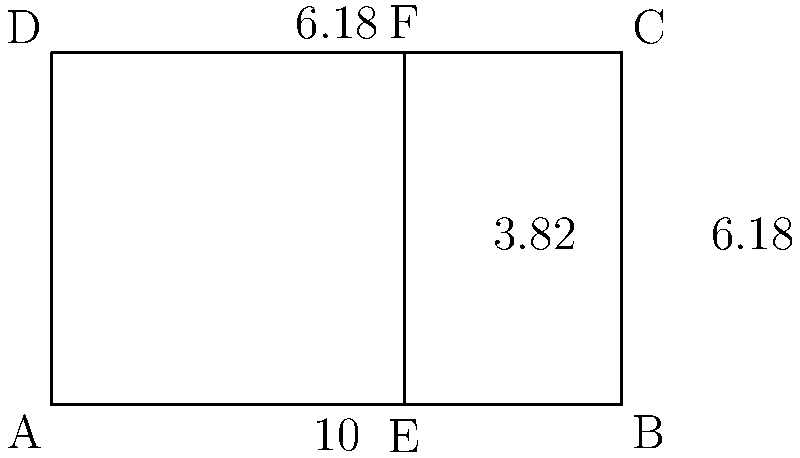In your latest architectural photograph of a building in Buenos Aires, you notice a rectangular facade with golden ratio proportions. The facade is 10 meters wide and 6.18 meters tall. If you divide this rectangle vertically to create two smaller rectangles, with the left rectangle being a perfect square, what is the area of the right rectangle in square meters? Let's approach this step-by-step:

1) The golden ratio is approximately 1.618. In this case, the ratio of width to height is 10 : 6.18, which is indeed the golden ratio.

2) To divide the rectangle according to the golden ratio, we need to find the point where:
   $\frac{\text{total width}}{\text{larger part}} = \frac{\text{larger part}}{\text{smaller part}} = \phi$ (golden ratio)

3) Let $x$ be the width of the square (smaller part). Then:
   $\frac{10}{10-x} = \frac{10-x}{x} = \phi$

4) This gives us the equation: $x^2 + 10x - 100 = 0$

5) Solving this quadratic equation:
   $x = \frac{-10 + \sqrt{100 + 400}}{2} = \frac{-10 + \sqrt{500}}{2} \approx 3.82$

6) So the width of the square (left rectangle) is approximately 3.82 meters.

7) The width of the right rectangle is therefore: $10 - 3.82 = 6.18$ meters

8) The height of both rectangles is 6.18 meters.

9) The area of the right rectangle is:
   $6.18 \times 6.18 = 38.1924$ square meters

Therefore, the area of the right rectangle is approximately 38.19 square meters.
Answer: 38.19 m² 